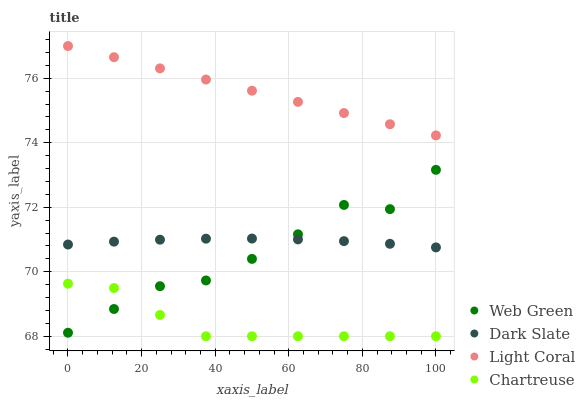Does Chartreuse have the minimum area under the curve?
Answer yes or no. Yes. Does Light Coral have the maximum area under the curve?
Answer yes or no. Yes. Does Dark Slate have the minimum area under the curve?
Answer yes or no. No. Does Dark Slate have the maximum area under the curve?
Answer yes or no. No. Is Light Coral the smoothest?
Answer yes or no. Yes. Is Web Green the roughest?
Answer yes or no. Yes. Is Dark Slate the smoothest?
Answer yes or no. No. Is Dark Slate the roughest?
Answer yes or no. No. Does Chartreuse have the lowest value?
Answer yes or no. Yes. Does Dark Slate have the lowest value?
Answer yes or no. No. Does Light Coral have the highest value?
Answer yes or no. Yes. Does Dark Slate have the highest value?
Answer yes or no. No. Is Dark Slate less than Light Coral?
Answer yes or no. Yes. Is Light Coral greater than Web Green?
Answer yes or no. Yes. Does Web Green intersect Chartreuse?
Answer yes or no. Yes. Is Web Green less than Chartreuse?
Answer yes or no. No. Is Web Green greater than Chartreuse?
Answer yes or no. No. Does Dark Slate intersect Light Coral?
Answer yes or no. No. 